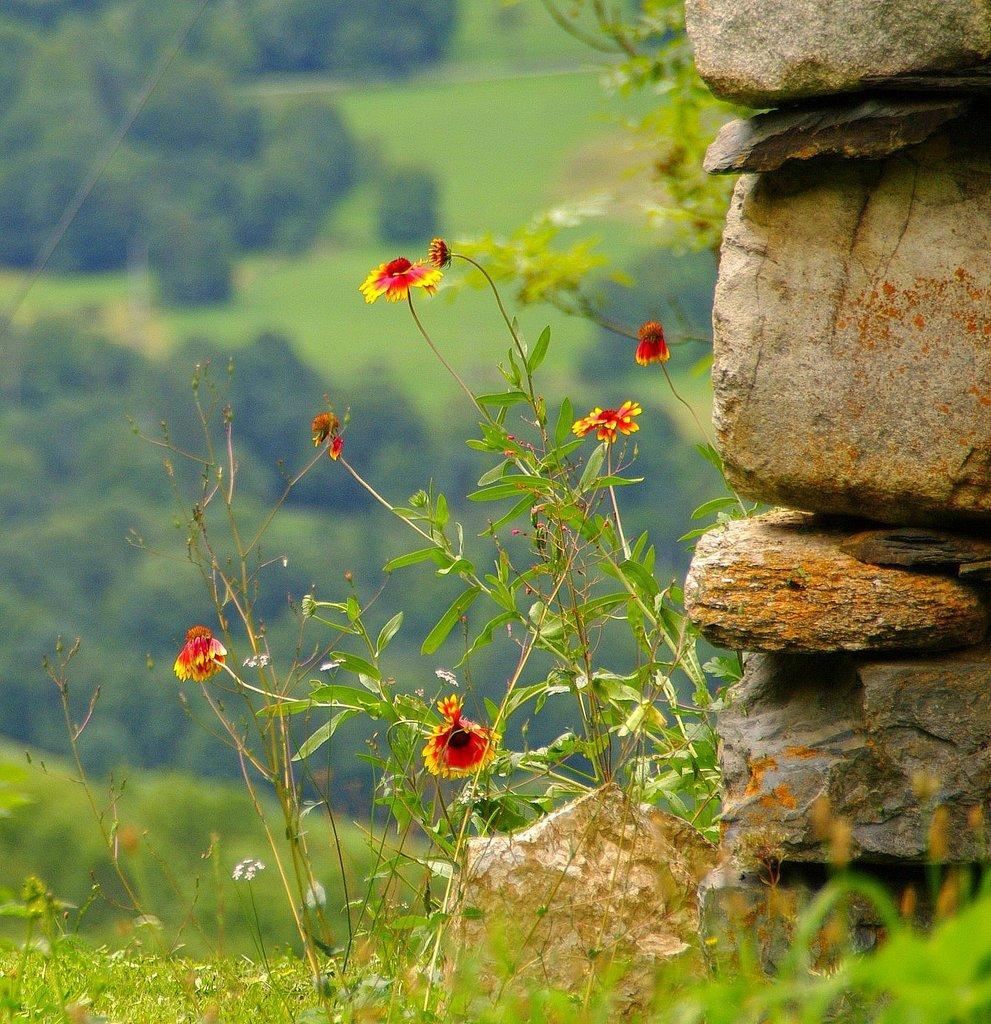Describe this image in one or two sentences. In this picture there are stones on the right side of the image and in the foreground there are flowers on the plant. At the back there are trees. At the bottom there is grass. 